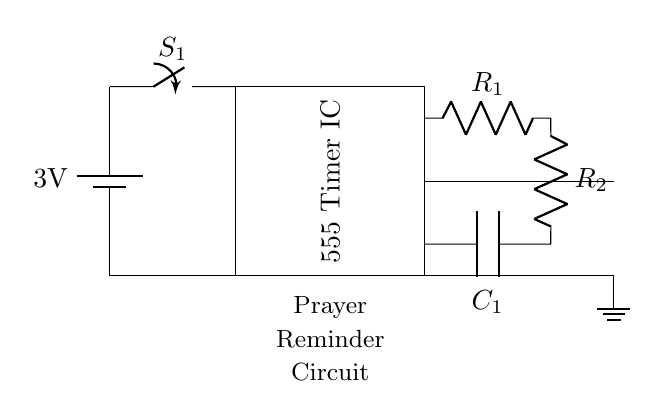What is the voltage of the battery? The battery is labeled as 3V in the circuit diagram, which indicates the voltage supplied to the circuit.
Answer: 3V What component is used for timing? The circuit uses a 555 Timer IC, which is shown in the rectangular box labeled within the diagram.
Answer: 555 Timer IC How many resistors are present in the circuit? There are two resistors labeled R1 and R2 connected in series in the circuit, indicated by the R symbols in the diagram.
Answer: 2 What does the buzzer do in this circuit? The buzzer is connected to the output of the timer, so it activates when the timer triggers, serving as an alert for the prayer reminder function.
Answer: Alerts What is the purpose of the capacitor? The capacitor, labeled as C1, is part of the timing component of the 555 Timer IC, helping to determine the timing interval along with the resistors.
Answer: Timing interval What is the grounding method in this circuit? The ground is established at the bottom of the circuit where all the negative terminals converge, indicated by the ground symbol, ensuring a common reference point.
Answer: Common reference Which component initiates the reminder? The reminder is initiated by the switch S1, which when closed, allows current to flow to the timer and subsequently to the buzzer.
Answer: Switch 